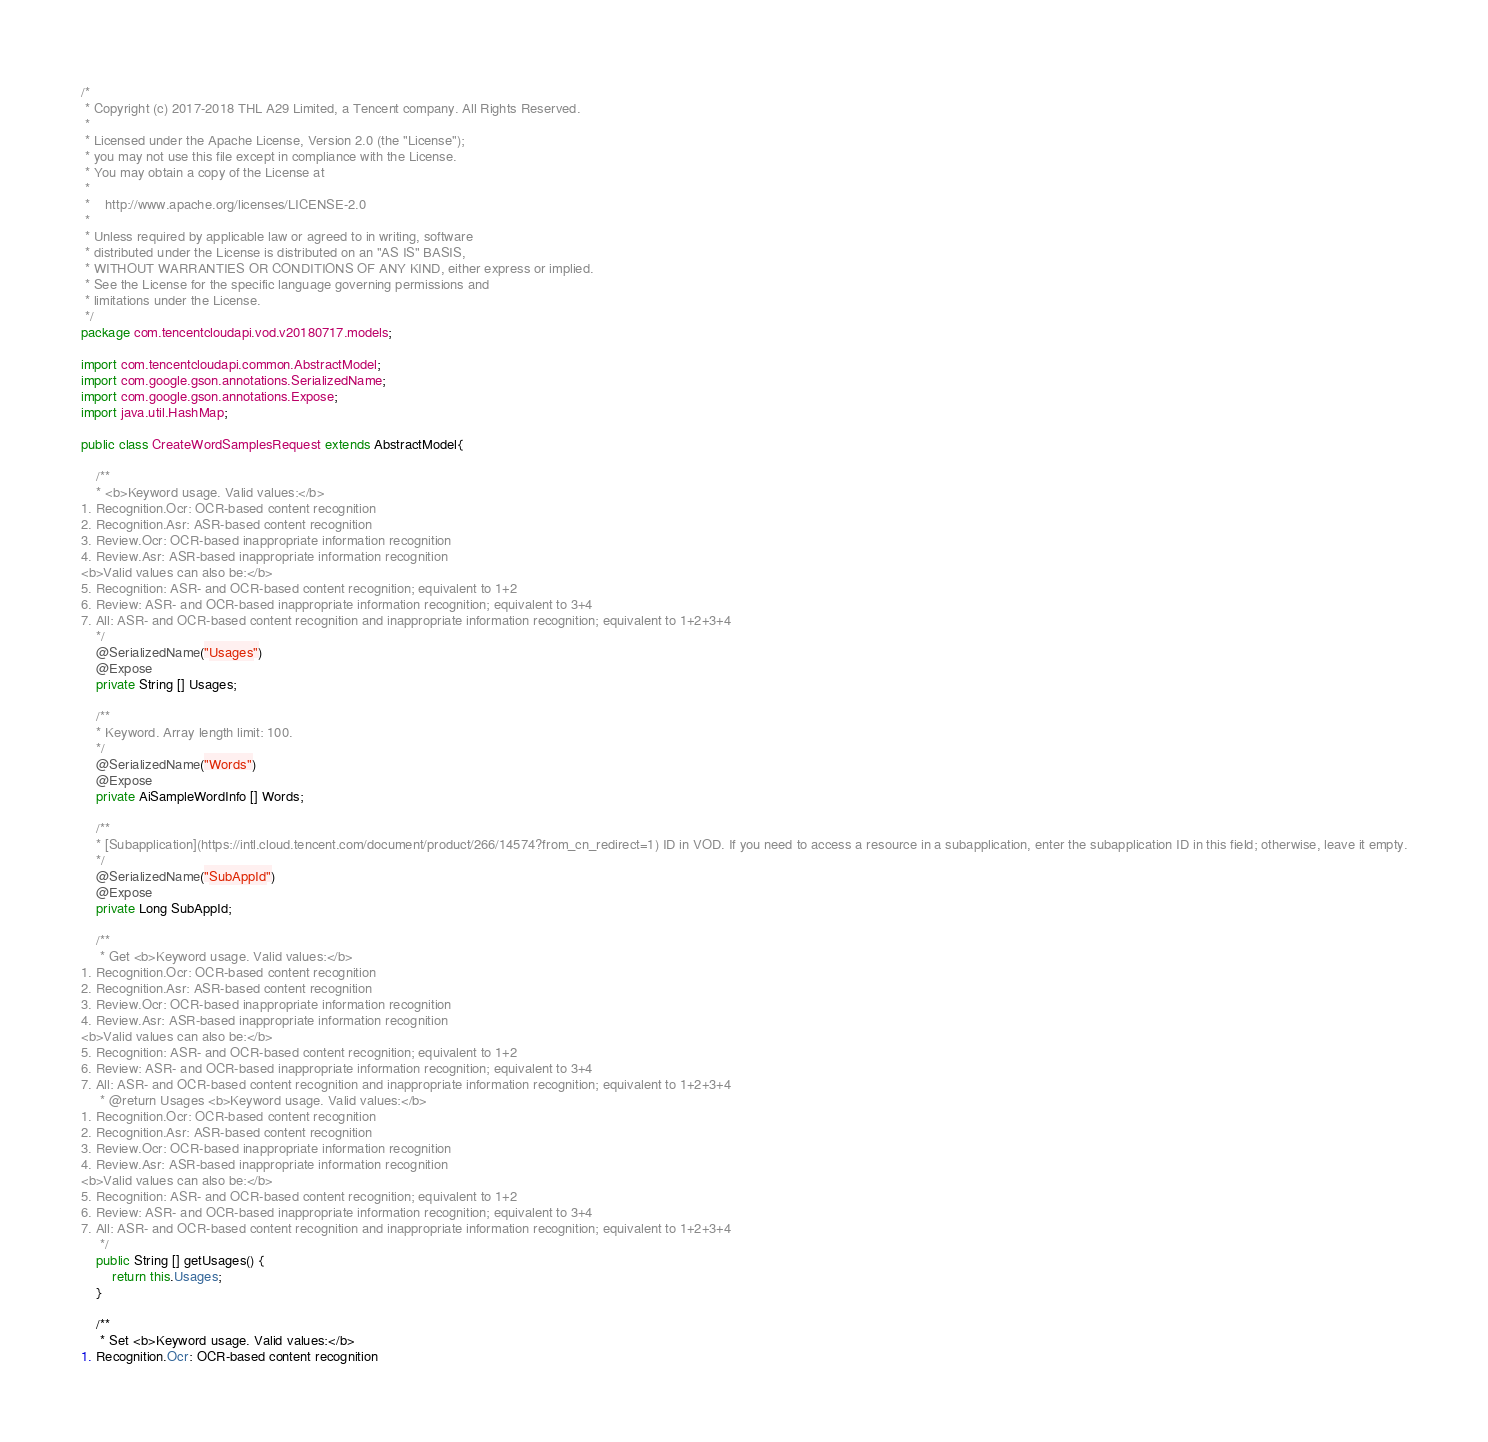Convert code to text. <code><loc_0><loc_0><loc_500><loc_500><_Java_>/*
 * Copyright (c) 2017-2018 THL A29 Limited, a Tencent company. All Rights Reserved.
 *
 * Licensed under the Apache License, Version 2.0 (the "License");
 * you may not use this file except in compliance with the License.
 * You may obtain a copy of the License at
 *
 *    http://www.apache.org/licenses/LICENSE-2.0
 *
 * Unless required by applicable law or agreed to in writing, software
 * distributed under the License is distributed on an "AS IS" BASIS,
 * WITHOUT WARRANTIES OR CONDITIONS OF ANY KIND, either express or implied.
 * See the License for the specific language governing permissions and
 * limitations under the License.
 */
package com.tencentcloudapi.vod.v20180717.models;

import com.tencentcloudapi.common.AbstractModel;
import com.google.gson.annotations.SerializedName;
import com.google.gson.annotations.Expose;
import java.util.HashMap;

public class CreateWordSamplesRequest extends AbstractModel{

    /**
    * <b>Keyword usage. Valid values:</b>
1. Recognition.Ocr: OCR-based content recognition
2. Recognition.Asr: ASR-based content recognition
3. Review.Ocr: OCR-based inappropriate information recognition
4. Review.Asr: ASR-based inappropriate information recognition
<b>Valid values can also be:</b>
5. Recognition: ASR- and OCR-based content recognition; equivalent to 1+2
6. Review: ASR- and OCR-based inappropriate information recognition; equivalent to 3+4
7. All: ASR- and OCR-based content recognition and inappropriate information recognition; equivalent to 1+2+3+4
    */
    @SerializedName("Usages")
    @Expose
    private String [] Usages;

    /**
    * Keyword. Array length limit: 100.
    */
    @SerializedName("Words")
    @Expose
    private AiSampleWordInfo [] Words;

    /**
    * [Subapplication](https://intl.cloud.tencent.com/document/product/266/14574?from_cn_redirect=1) ID in VOD. If you need to access a resource in a subapplication, enter the subapplication ID in this field; otherwise, leave it empty.
    */
    @SerializedName("SubAppId")
    @Expose
    private Long SubAppId;

    /**
     * Get <b>Keyword usage. Valid values:</b>
1. Recognition.Ocr: OCR-based content recognition
2. Recognition.Asr: ASR-based content recognition
3. Review.Ocr: OCR-based inappropriate information recognition
4. Review.Asr: ASR-based inappropriate information recognition
<b>Valid values can also be:</b>
5. Recognition: ASR- and OCR-based content recognition; equivalent to 1+2
6. Review: ASR- and OCR-based inappropriate information recognition; equivalent to 3+4
7. All: ASR- and OCR-based content recognition and inappropriate information recognition; equivalent to 1+2+3+4 
     * @return Usages <b>Keyword usage. Valid values:</b>
1. Recognition.Ocr: OCR-based content recognition
2. Recognition.Asr: ASR-based content recognition
3. Review.Ocr: OCR-based inappropriate information recognition
4. Review.Asr: ASR-based inappropriate information recognition
<b>Valid values can also be:</b>
5. Recognition: ASR- and OCR-based content recognition; equivalent to 1+2
6. Review: ASR- and OCR-based inappropriate information recognition; equivalent to 3+4
7. All: ASR- and OCR-based content recognition and inappropriate information recognition; equivalent to 1+2+3+4
     */
    public String [] getUsages() {
        return this.Usages;
    }

    /**
     * Set <b>Keyword usage. Valid values:</b>
1. Recognition.Ocr: OCR-based content recognition</code> 